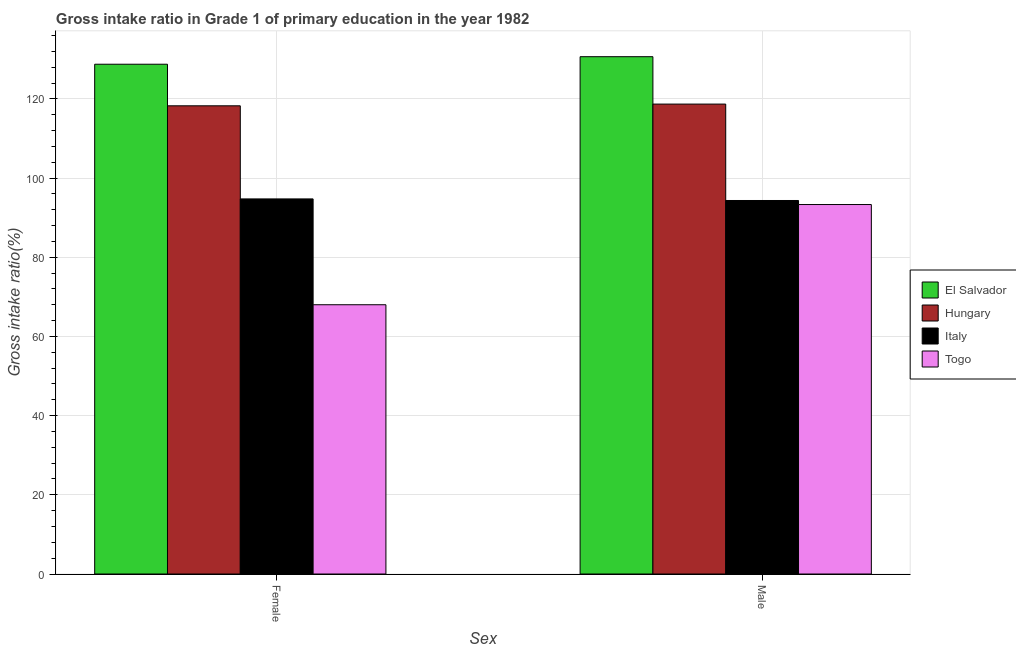How many groups of bars are there?
Offer a terse response. 2. Are the number of bars on each tick of the X-axis equal?
Ensure brevity in your answer.  Yes. How many bars are there on the 1st tick from the right?
Your answer should be compact. 4. What is the gross intake ratio(female) in Hungary?
Offer a terse response. 118.26. Across all countries, what is the maximum gross intake ratio(male)?
Offer a terse response. 130.67. Across all countries, what is the minimum gross intake ratio(male)?
Keep it short and to the point. 93.33. In which country was the gross intake ratio(female) maximum?
Make the answer very short. El Salvador. In which country was the gross intake ratio(female) minimum?
Give a very brief answer. Togo. What is the total gross intake ratio(female) in the graph?
Your response must be concise. 409.79. What is the difference between the gross intake ratio(male) in Italy and that in Togo?
Ensure brevity in your answer.  1.02. What is the difference between the gross intake ratio(female) in Hungary and the gross intake ratio(male) in Italy?
Offer a terse response. 23.92. What is the average gross intake ratio(male) per country?
Your answer should be compact. 109.26. What is the difference between the gross intake ratio(female) and gross intake ratio(male) in El Salvador?
Keep it short and to the point. -1.9. What is the ratio of the gross intake ratio(male) in Togo to that in Hungary?
Ensure brevity in your answer.  0.79. What does the 4th bar from the left in Male represents?
Ensure brevity in your answer.  Togo. What does the 1st bar from the right in Female represents?
Make the answer very short. Togo. How many countries are there in the graph?
Offer a terse response. 4. What is the difference between two consecutive major ticks on the Y-axis?
Provide a succinct answer. 20. Are the values on the major ticks of Y-axis written in scientific E-notation?
Your response must be concise. No. Does the graph contain grids?
Make the answer very short. Yes. How many legend labels are there?
Give a very brief answer. 4. How are the legend labels stacked?
Give a very brief answer. Vertical. What is the title of the graph?
Keep it short and to the point. Gross intake ratio in Grade 1 of primary education in the year 1982. Does "China" appear as one of the legend labels in the graph?
Provide a succinct answer. No. What is the label or title of the X-axis?
Give a very brief answer. Sex. What is the label or title of the Y-axis?
Give a very brief answer. Gross intake ratio(%). What is the Gross intake ratio(%) in El Salvador in Female?
Your answer should be very brief. 128.77. What is the Gross intake ratio(%) of Hungary in Female?
Provide a short and direct response. 118.26. What is the Gross intake ratio(%) in Italy in Female?
Keep it short and to the point. 94.74. What is the Gross intake ratio(%) in Togo in Female?
Provide a short and direct response. 68.01. What is the Gross intake ratio(%) in El Salvador in Male?
Ensure brevity in your answer.  130.67. What is the Gross intake ratio(%) in Hungary in Male?
Your answer should be very brief. 118.7. What is the Gross intake ratio(%) of Italy in Male?
Make the answer very short. 94.34. What is the Gross intake ratio(%) of Togo in Male?
Keep it short and to the point. 93.33. Across all Sex, what is the maximum Gross intake ratio(%) of El Salvador?
Your answer should be very brief. 130.67. Across all Sex, what is the maximum Gross intake ratio(%) of Hungary?
Your answer should be compact. 118.7. Across all Sex, what is the maximum Gross intake ratio(%) in Italy?
Give a very brief answer. 94.74. Across all Sex, what is the maximum Gross intake ratio(%) in Togo?
Your answer should be compact. 93.33. Across all Sex, what is the minimum Gross intake ratio(%) of El Salvador?
Your answer should be very brief. 128.77. Across all Sex, what is the minimum Gross intake ratio(%) of Hungary?
Provide a short and direct response. 118.26. Across all Sex, what is the minimum Gross intake ratio(%) in Italy?
Offer a terse response. 94.34. Across all Sex, what is the minimum Gross intake ratio(%) of Togo?
Give a very brief answer. 68.01. What is the total Gross intake ratio(%) in El Salvador in the graph?
Keep it short and to the point. 259.44. What is the total Gross intake ratio(%) in Hungary in the graph?
Provide a short and direct response. 236.96. What is the total Gross intake ratio(%) of Italy in the graph?
Your answer should be very brief. 189.09. What is the total Gross intake ratio(%) of Togo in the graph?
Make the answer very short. 161.34. What is the difference between the Gross intake ratio(%) of El Salvador in Female and that in Male?
Your response must be concise. -1.9. What is the difference between the Gross intake ratio(%) in Hungary in Female and that in Male?
Provide a succinct answer. -0.44. What is the difference between the Gross intake ratio(%) of Italy in Female and that in Male?
Provide a short and direct response. 0.4. What is the difference between the Gross intake ratio(%) in Togo in Female and that in Male?
Provide a succinct answer. -25.31. What is the difference between the Gross intake ratio(%) in El Salvador in Female and the Gross intake ratio(%) in Hungary in Male?
Give a very brief answer. 10.07. What is the difference between the Gross intake ratio(%) of El Salvador in Female and the Gross intake ratio(%) of Italy in Male?
Provide a succinct answer. 34.42. What is the difference between the Gross intake ratio(%) in El Salvador in Female and the Gross intake ratio(%) in Togo in Male?
Make the answer very short. 35.44. What is the difference between the Gross intake ratio(%) of Hungary in Female and the Gross intake ratio(%) of Italy in Male?
Make the answer very short. 23.92. What is the difference between the Gross intake ratio(%) of Hungary in Female and the Gross intake ratio(%) of Togo in Male?
Provide a succinct answer. 24.94. What is the difference between the Gross intake ratio(%) in Italy in Female and the Gross intake ratio(%) in Togo in Male?
Keep it short and to the point. 1.42. What is the average Gross intake ratio(%) of El Salvador per Sex?
Your answer should be compact. 129.72. What is the average Gross intake ratio(%) of Hungary per Sex?
Provide a short and direct response. 118.48. What is the average Gross intake ratio(%) in Italy per Sex?
Provide a short and direct response. 94.54. What is the average Gross intake ratio(%) in Togo per Sex?
Keep it short and to the point. 80.67. What is the difference between the Gross intake ratio(%) in El Salvador and Gross intake ratio(%) in Hungary in Female?
Your answer should be compact. 10.5. What is the difference between the Gross intake ratio(%) of El Salvador and Gross intake ratio(%) of Italy in Female?
Make the answer very short. 34.02. What is the difference between the Gross intake ratio(%) of El Salvador and Gross intake ratio(%) of Togo in Female?
Your response must be concise. 60.75. What is the difference between the Gross intake ratio(%) of Hungary and Gross intake ratio(%) of Italy in Female?
Offer a very short reply. 23.52. What is the difference between the Gross intake ratio(%) of Hungary and Gross intake ratio(%) of Togo in Female?
Make the answer very short. 50.25. What is the difference between the Gross intake ratio(%) in Italy and Gross intake ratio(%) in Togo in Female?
Make the answer very short. 26.73. What is the difference between the Gross intake ratio(%) in El Salvador and Gross intake ratio(%) in Hungary in Male?
Make the answer very short. 11.97. What is the difference between the Gross intake ratio(%) in El Salvador and Gross intake ratio(%) in Italy in Male?
Your response must be concise. 36.33. What is the difference between the Gross intake ratio(%) of El Salvador and Gross intake ratio(%) of Togo in Male?
Your answer should be compact. 37.34. What is the difference between the Gross intake ratio(%) of Hungary and Gross intake ratio(%) of Italy in Male?
Provide a succinct answer. 24.35. What is the difference between the Gross intake ratio(%) in Hungary and Gross intake ratio(%) in Togo in Male?
Your answer should be compact. 25.37. What is the difference between the Gross intake ratio(%) of Italy and Gross intake ratio(%) of Togo in Male?
Keep it short and to the point. 1.02. What is the ratio of the Gross intake ratio(%) in El Salvador in Female to that in Male?
Provide a short and direct response. 0.99. What is the ratio of the Gross intake ratio(%) in Hungary in Female to that in Male?
Offer a very short reply. 1. What is the ratio of the Gross intake ratio(%) of Italy in Female to that in Male?
Provide a short and direct response. 1. What is the ratio of the Gross intake ratio(%) of Togo in Female to that in Male?
Your answer should be compact. 0.73. What is the difference between the highest and the second highest Gross intake ratio(%) of El Salvador?
Keep it short and to the point. 1.9. What is the difference between the highest and the second highest Gross intake ratio(%) of Hungary?
Make the answer very short. 0.44. What is the difference between the highest and the second highest Gross intake ratio(%) in Italy?
Offer a terse response. 0.4. What is the difference between the highest and the second highest Gross intake ratio(%) in Togo?
Provide a short and direct response. 25.31. What is the difference between the highest and the lowest Gross intake ratio(%) in El Salvador?
Ensure brevity in your answer.  1.9. What is the difference between the highest and the lowest Gross intake ratio(%) in Hungary?
Your response must be concise. 0.44. What is the difference between the highest and the lowest Gross intake ratio(%) of Italy?
Offer a very short reply. 0.4. What is the difference between the highest and the lowest Gross intake ratio(%) in Togo?
Your answer should be compact. 25.31. 